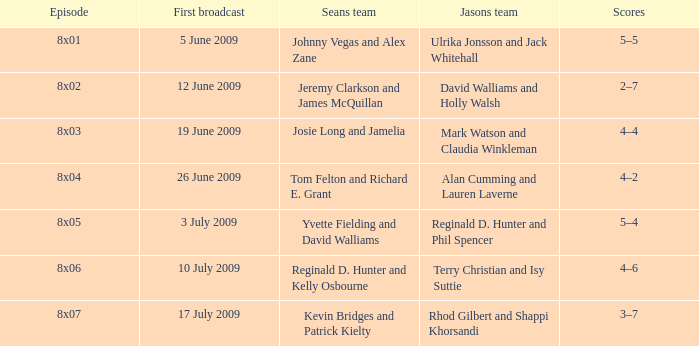Who was on Jason's team in the episode where Sean's team was Reginald D. Hunter and Kelly Osbourne? Terry Christian and Isy Suttie. 